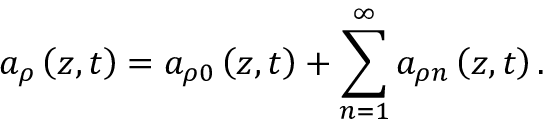Convert formula to latex. <formula><loc_0><loc_0><loc_500><loc_500>a _ { \rho } \left ( z , t \right ) = a _ { \rho 0 } \left ( z , t \right ) + \sum _ { n = 1 } ^ { \infty } a _ { \rho n } \left ( z , t \right ) .</formula> 